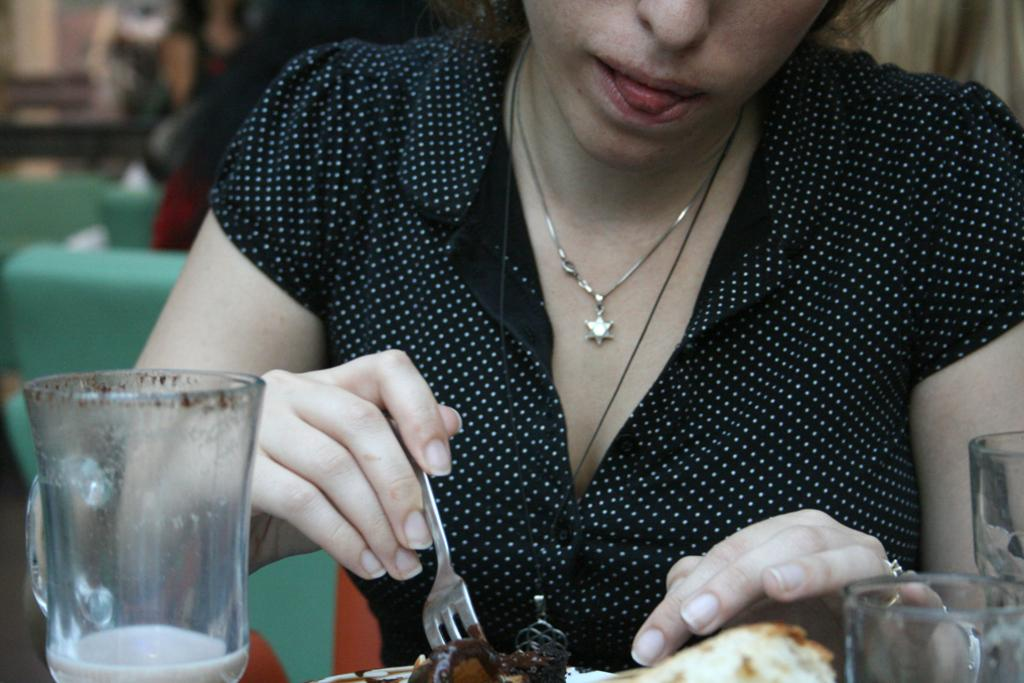Who is present in the image? There is a woman in the image. What is the woman doing in the image? The woman is eating a food item. Can you describe the setting or context of the image? There are glasses around the food item, which suggests a dining or eating environment. What type of hole can be seen in the image? There is no hole present in the image. Can you describe the cherry on top of the food item? There is no cherry mentioned in the image, so it cannot be described. 